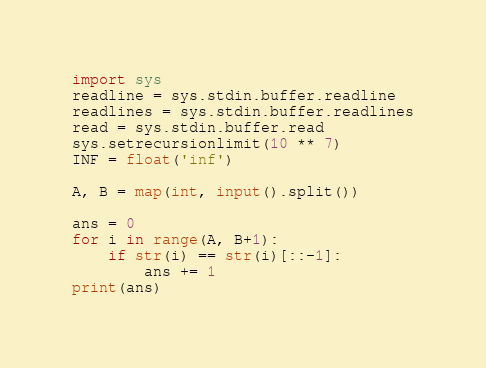<code> <loc_0><loc_0><loc_500><loc_500><_Python_>import sys
readline = sys.stdin.buffer.readline
readlines = sys.stdin.buffer.readlines
read = sys.stdin.buffer.read
sys.setrecursionlimit(10 ** 7)
INF = float('inf')

A, B = map(int, input().split())

ans = 0
for i in range(A, B+1):
    if str(i) == str(i)[::-1]:
        ans += 1
print(ans)</code> 